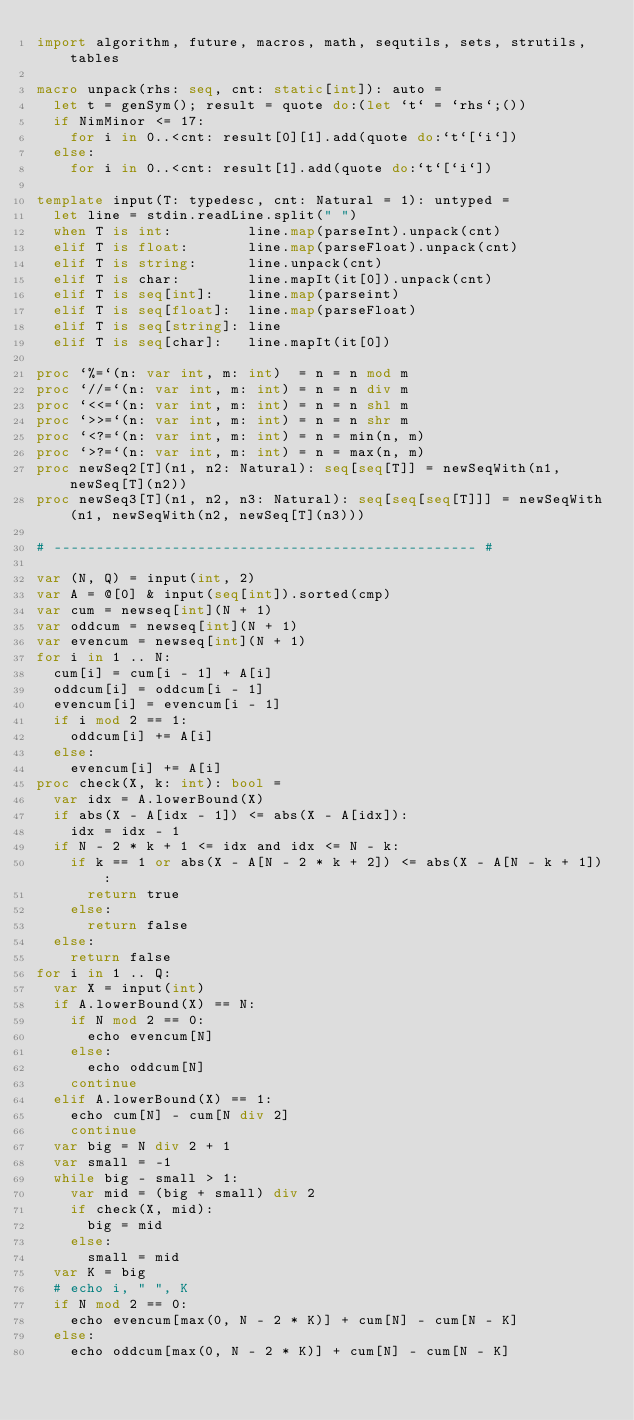Convert code to text. <code><loc_0><loc_0><loc_500><loc_500><_Nim_>import algorithm, future, macros, math, sequtils, sets, strutils, tables

macro unpack(rhs: seq, cnt: static[int]): auto =
  let t = genSym(); result = quote do:(let `t` = `rhs`;())
  if NimMinor <= 17:
    for i in 0..<cnt: result[0][1].add(quote do:`t`[`i`])
  else:
    for i in 0..<cnt: result[1].add(quote do:`t`[`i`])

template input(T: typedesc, cnt: Natural = 1): untyped =
  let line = stdin.readLine.split(" ")
  when T is int:         line.map(parseInt).unpack(cnt)
  elif T is float:       line.map(parseFloat).unpack(cnt)
  elif T is string:      line.unpack(cnt)
  elif T is char:        line.mapIt(it[0]).unpack(cnt)
  elif T is seq[int]:    line.map(parseint)
  elif T is seq[float]:  line.map(parseFloat)
  elif T is seq[string]: line
  elif T is seq[char]:   line.mapIt(it[0])

proc `%=`(n: var int, m: int)  = n = n mod m
proc `//=`(n: var int, m: int) = n = n div m
proc `<<=`(n: var int, m: int) = n = n shl m
proc `>>=`(n: var int, m: int) = n = n shr m
proc `<?=`(n: var int, m: int) = n = min(n, m)
proc `>?=`(n: var int, m: int) = n = max(n, m)
proc newSeq2[T](n1, n2: Natural): seq[seq[T]] = newSeqWith(n1, newSeq[T](n2))
proc newSeq3[T](n1, n2, n3: Natural): seq[seq[seq[T]]] = newSeqWith(n1, newSeqWith(n2, newSeq[T](n3)))

# -------------------------------------------------- #

var (N, Q) = input(int, 2)
var A = @[0] & input(seq[int]).sorted(cmp)
var cum = newseq[int](N + 1)
var oddcum = newseq[int](N + 1)
var evencum = newseq[int](N + 1)
for i in 1 .. N:
  cum[i] = cum[i - 1] + A[i]
  oddcum[i] = oddcum[i - 1]
  evencum[i] = evencum[i - 1]
  if i mod 2 == 1:
    oddcum[i] += A[i]
  else:
    evencum[i] += A[i]
proc check(X, k: int): bool =
  var idx = A.lowerBound(X)
  if abs(X - A[idx - 1]) <= abs(X - A[idx]):
    idx = idx - 1
  if N - 2 * k + 1 <= idx and idx <= N - k:
    if k == 1 or abs(X - A[N - 2 * k + 2]) <= abs(X - A[N - k + 1]):
      return true
    else:
      return false
  else:
    return false
for i in 1 .. Q:
  var X = input(int)
  if A.lowerBound(X) == N:
    if N mod 2 == 0:
      echo evencum[N]
    else:
      echo oddcum[N]
    continue
  elif A.lowerBound(X) == 1:
    echo cum[N] - cum[N div 2]
    continue
  var big = N div 2 + 1
  var small = -1
  while big - small > 1:
    var mid = (big + small) div 2
    if check(X, mid):
      big = mid
    else:
      small = mid
  var K = big
  # echo i, " ", K
  if N mod 2 == 0:
    echo evencum[max(0, N - 2 * K)] + cum[N] - cum[N - K]
  else:
    echo oddcum[max(0, N - 2 * K)] + cum[N] - cum[N - K]</code> 